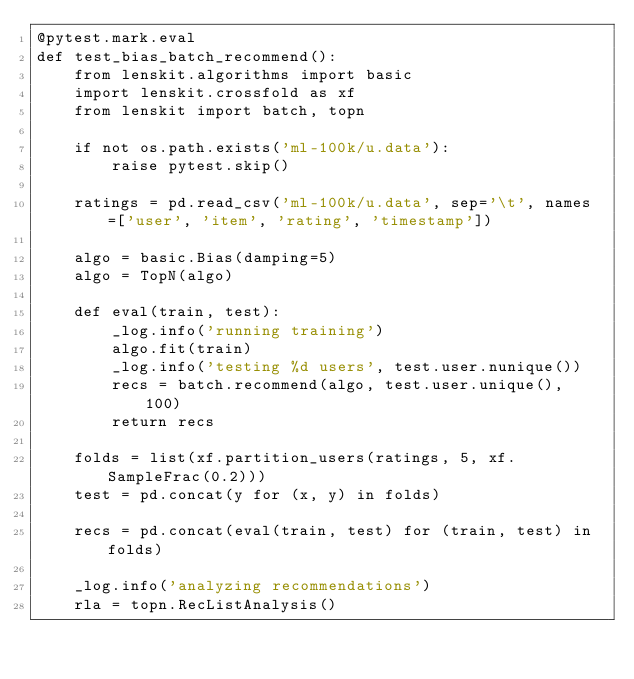Convert code to text. <code><loc_0><loc_0><loc_500><loc_500><_Python_>@pytest.mark.eval
def test_bias_batch_recommend():
    from lenskit.algorithms import basic
    import lenskit.crossfold as xf
    from lenskit import batch, topn

    if not os.path.exists('ml-100k/u.data'):
        raise pytest.skip()

    ratings = pd.read_csv('ml-100k/u.data', sep='\t', names=['user', 'item', 'rating', 'timestamp'])

    algo = basic.Bias(damping=5)
    algo = TopN(algo)

    def eval(train, test):
        _log.info('running training')
        algo.fit(train)
        _log.info('testing %d users', test.user.nunique())
        recs = batch.recommend(algo, test.user.unique(), 100)
        return recs

    folds = list(xf.partition_users(ratings, 5, xf.SampleFrac(0.2)))
    test = pd.concat(y for (x, y) in folds)

    recs = pd.concat(eval(train, test) for (train, test) in folds)

    _log.info('analyzing recommendations')
    rla = topn.RecListAnalysis()</code> 